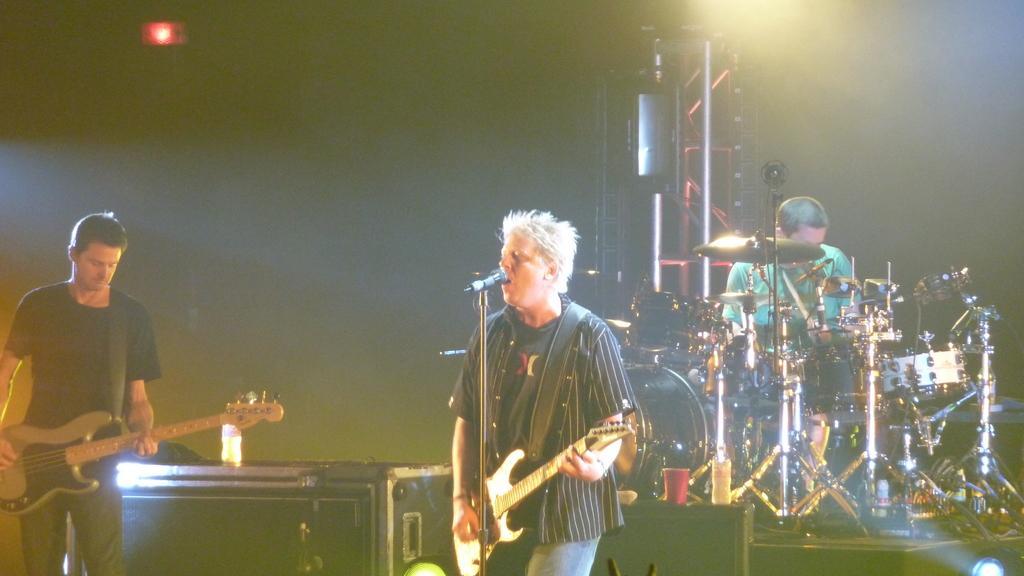Can you describe this image briefly? In this picture we can see man holding guitar in his hand and playing it and singing on mic and beside to him one person playing drums and other person standing and holding guitar in his hand and in background we can see light, pillar. 